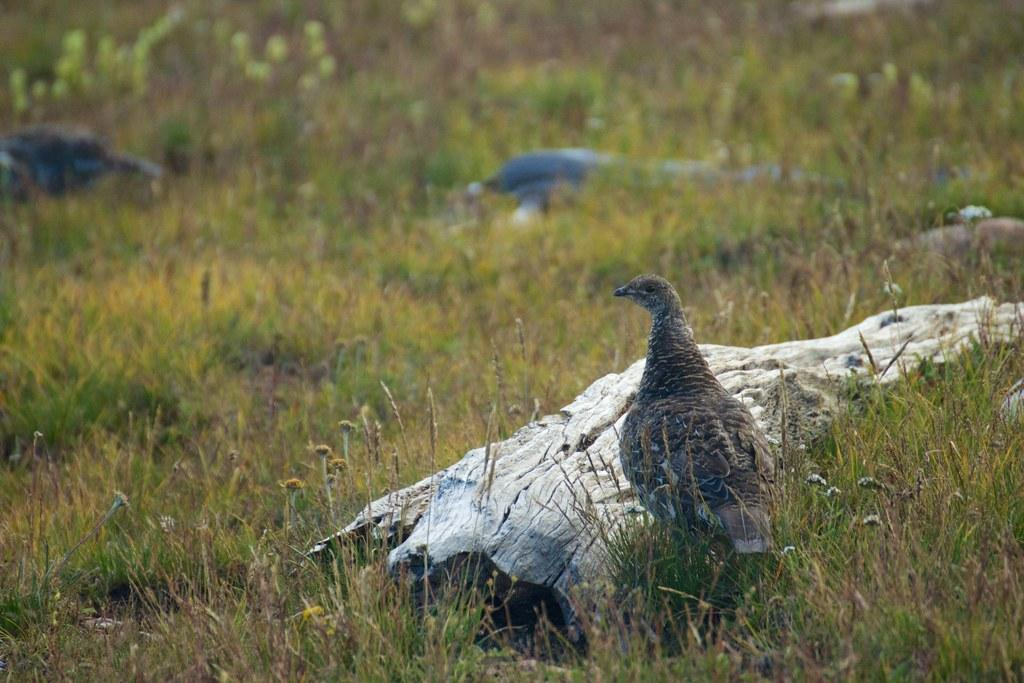What type of animals can be seen on the ground in the image? There are birds on the ground in the image. What kind of vegetation is present in the image? There are plants with flowers in the image. What type of ground cover can be seen in the image? Grass is present in the image. What other object can be seen in the image? There is a wooden log in the image. What type of hole can be seen in the image? There is no hole present in the image. What type of spoon is being used by the birds in the image? There are no birds using a spoon in the image. 